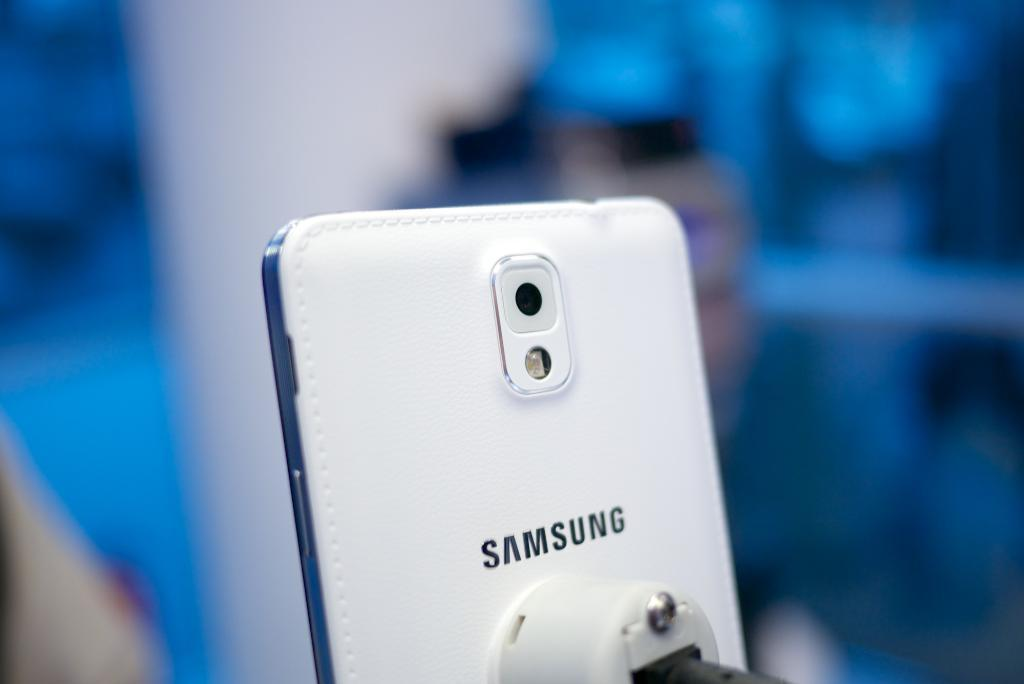<image>
Relay a brief, clear account of the picture shown. A Samsung product has a plug going into it. 